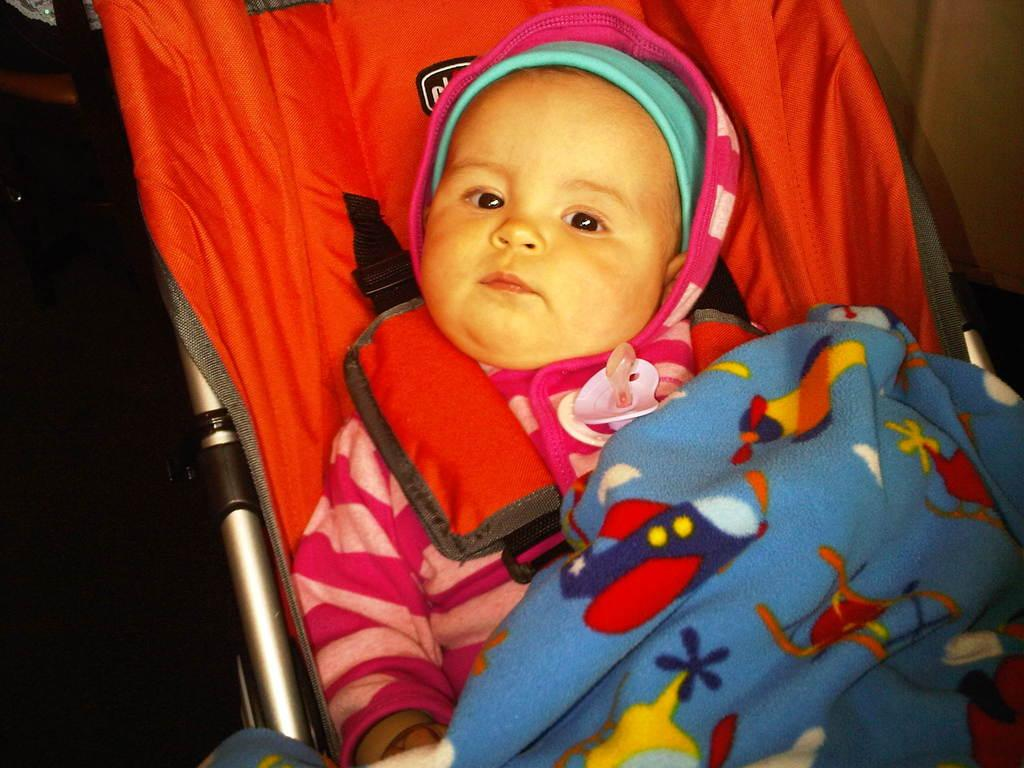What is the main subject of the image? There is a baby in the image. What is the baby wearing? The baby is wearing a pink dress. What is covering the baby? The baby is covered by a blue blanket. Where is the baby located in the image? The baby is sitting inside a baby cradle. What type of pot is being used to feed the baby in the image? There is no pot present in the image, and the baby is not being fed in the image. 